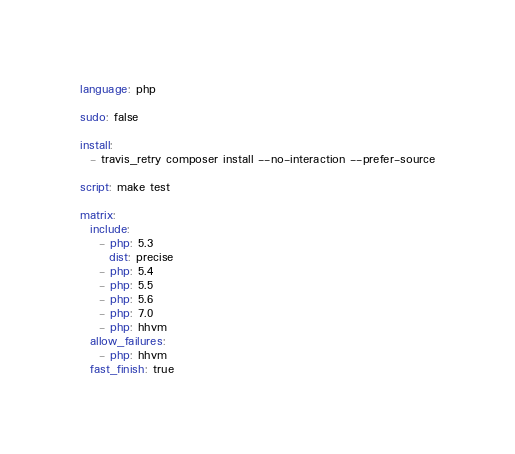Convert code to text. <code><loc_0><loc_0><loc_500><loc_500><_YAML_>language: php

sudo: false

install:
  - travis_retry composer install --no-interaction --prefer-source

script: make test

matrix:
  include:
    - php: 5.3
      dist: precise
    - php: 5.4
    - php: 5.5
    - php: 5.6
    - php: 7.0
    - php: hhvm
  allow_failures:
    - php: hhvm
  fast_finish: true
</code> 